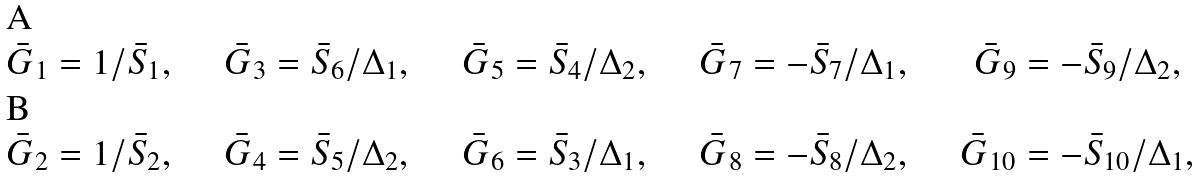<formula> <loc_0><loc_0><loc_500><loc_500>\bar { G } _ { 1 } & = 1 / \bar { S } _ { 1 } , \quad & \bar { G } _ { 3 } & = \bar { S } _ { 6 } / \Delta _ { 1 } , \quad & \bar { G } _ { 5 } & = \bar { S } _ { 4 } / \Delta _ { 2 } , \quad & \bar { G } _ { 7 } & = - \bar { S } _ { 7 } / \Delta _ { 1 } , \quad & \bar { G } _ { 9 } & = - \bar { S } _ { 9 } / \Delta _ { 2 } , \\ \bar { G } _ { 2 } & = 1 / \bar { S } _ { 2 } , \quad & \bar { G } _ { 4 } & = \bar { S } _ { 5 } / \Delta _ { 2 } , \quad & \bar { G } _ { 6 } & = \bar { S } _ { 3 } / \Delta _ { 1 } , \quad & \bar { G } _ { 8 } & = - \bar { S } _ { 8 } / \Delta _ { 2 } , \quad & \bar { G } _ { 1 0 } & = - \bar { S } _ { 1 0 } / \Delta _ { 1 } ,</formula> 